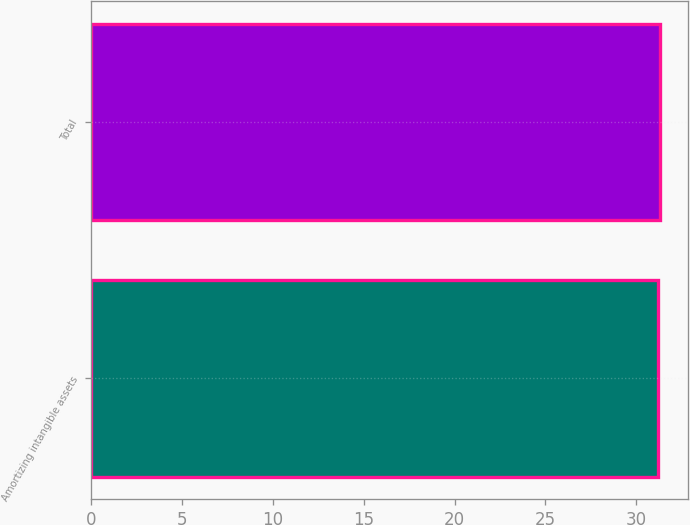<chart> <loc_0><loc_0><loc_500><loc_500><bar_chart><fcel>Amortizing intangible assets<fcel>Total<nl><fcel>31.2<fcel>31.3<nl></chart> 